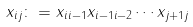<formula> <loc_0><loc_0><loc_500><loc_500>x _ { i j } \colon = x _ { i i - 1 } x _ { i - 1 i - 2 } \cdots x _ { j + 1 j }</formula> 